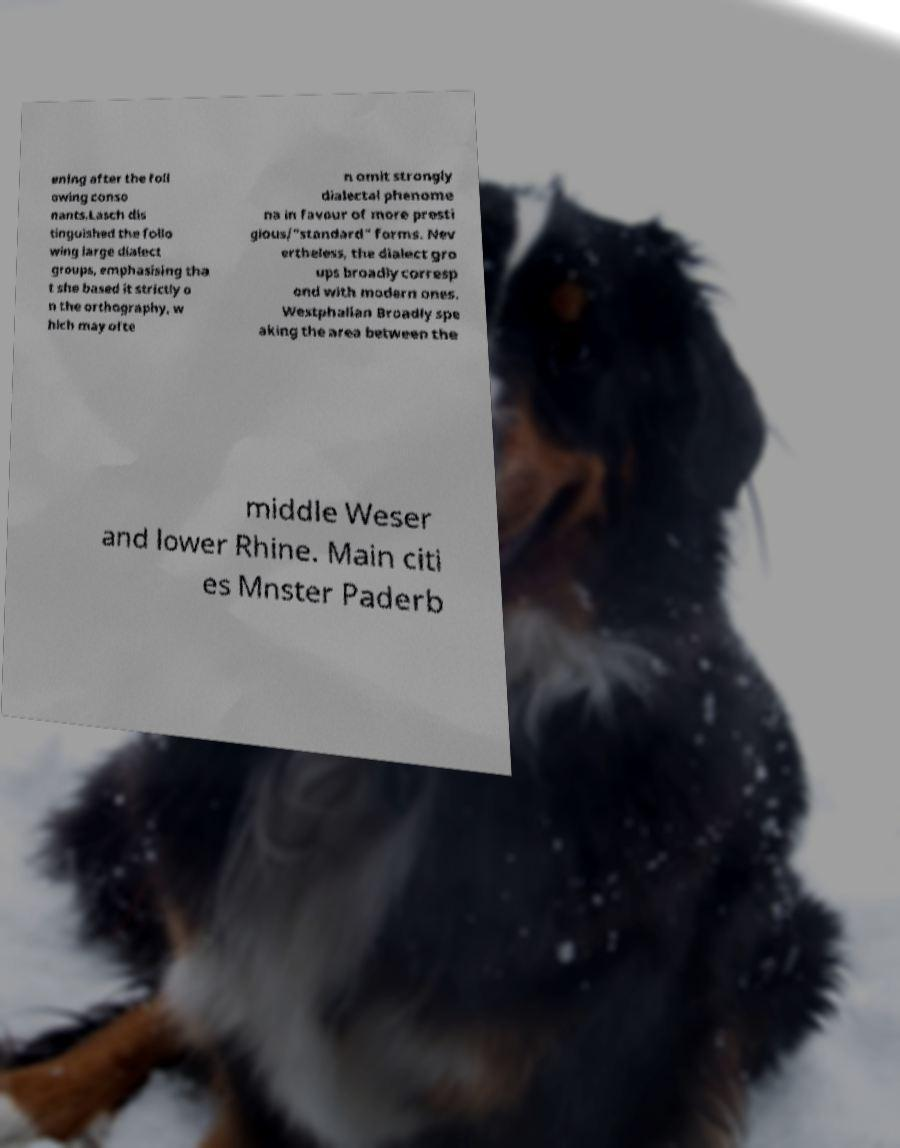Can you accurately transcribe the text from the provided image for me? ening after the foll owing conso nants.Lasch dis tinguished the follo wing large dialect groups, emphasising tha t she based it strictly o n the orthography, w hich may ofte n omit strongly dialectal phenome na in favour of more presti gious/"standard" forms. Nev ertheless, the dialect gro ups broadly corresp ond with modern ones. Westphalian Broadly spe aking the area between the middle Weser and lower Rhine. Main citi es Mnster Paderb 